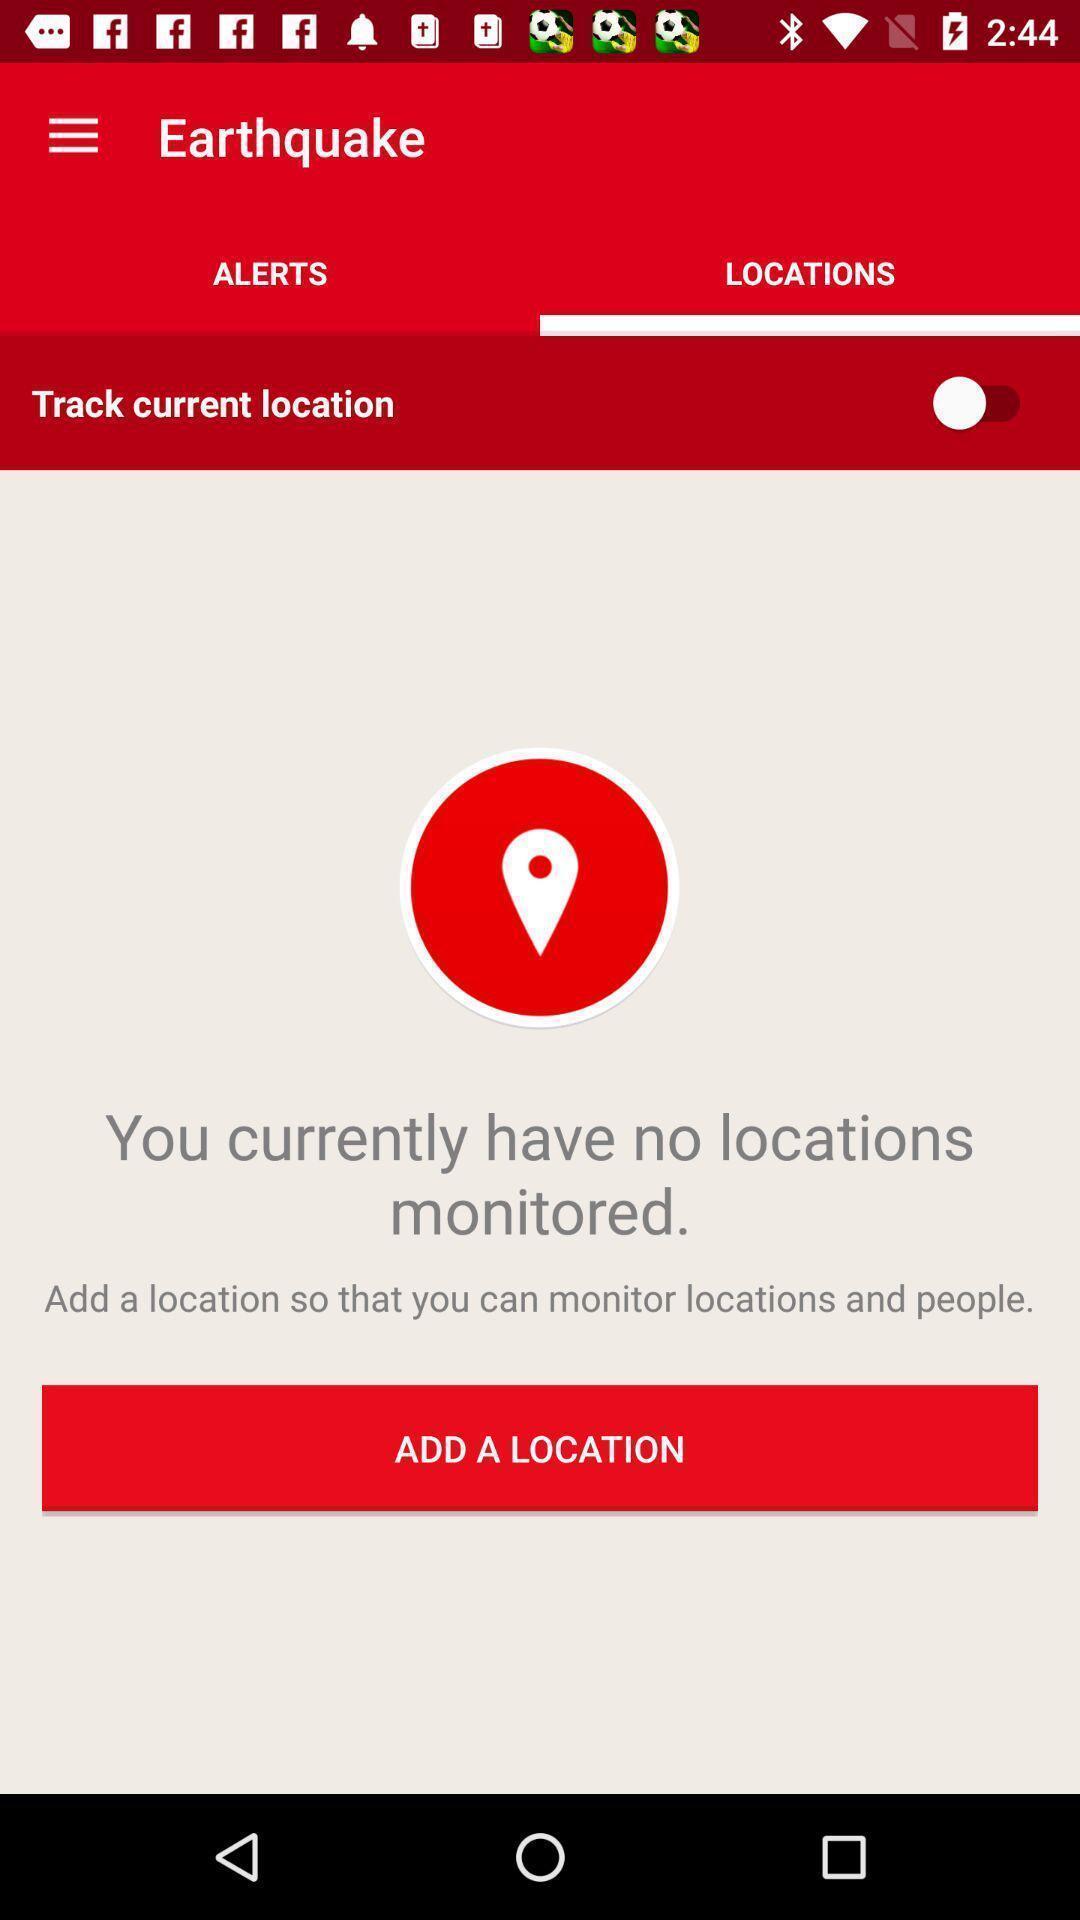Describe this image in words. Screen showing locations page. 